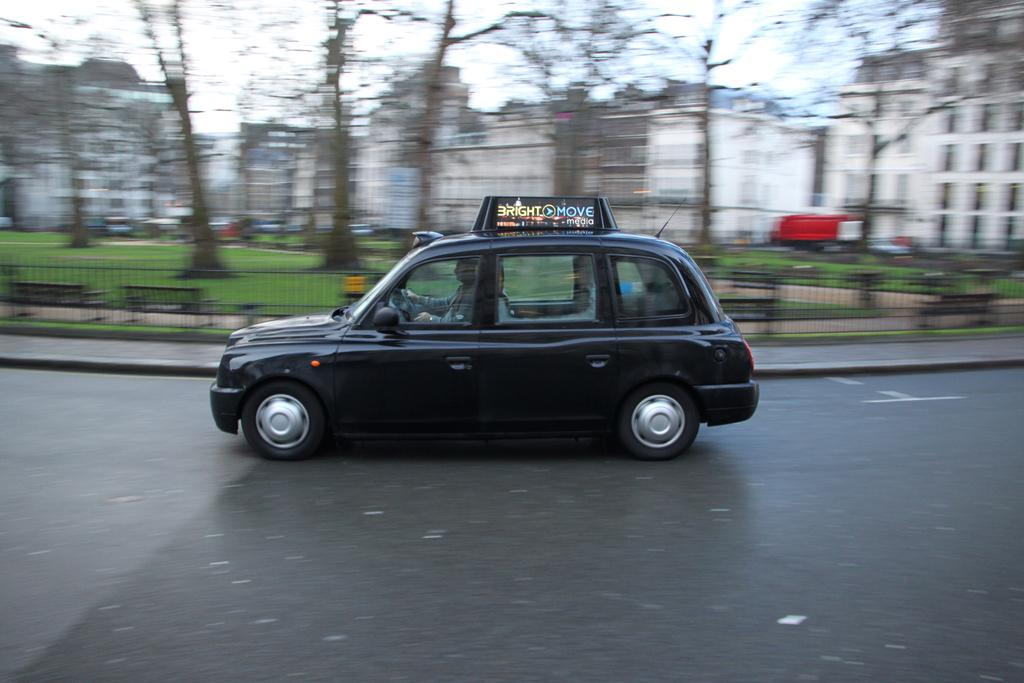What color is the car in the image? The car in the image is black. Where is the car located in the image? The car is on the road in the image. What can be seen in the background of the image? There are buildings, trees, and fencing in the background of the image. How many cherries are on the car in the image? There are no cherries present on the car in the image. What type of cows can be seen grazing near the car in the image? There are no cows present in the image; it only features a black color car on the road with buildings, trees, and fencing in the background. 